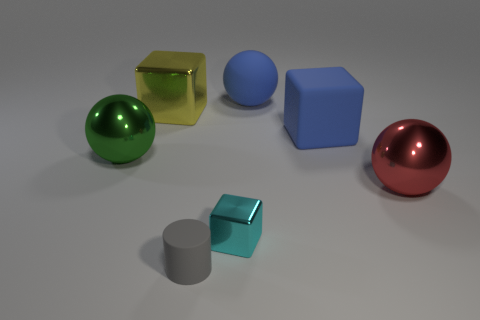Add 2 big blue things. How many objects exist? 9 Subtract all cylinders. How many objects are left? 6 Add 5 matte objects. How many matte objects exist? 8 Subtract 1 cyan cubes. How many objects are left? 6 Subtract all small objects. Subtract all green metal balls. How many objects are left? 4 Add 6 blue objects. How many blue objects are left? 8 